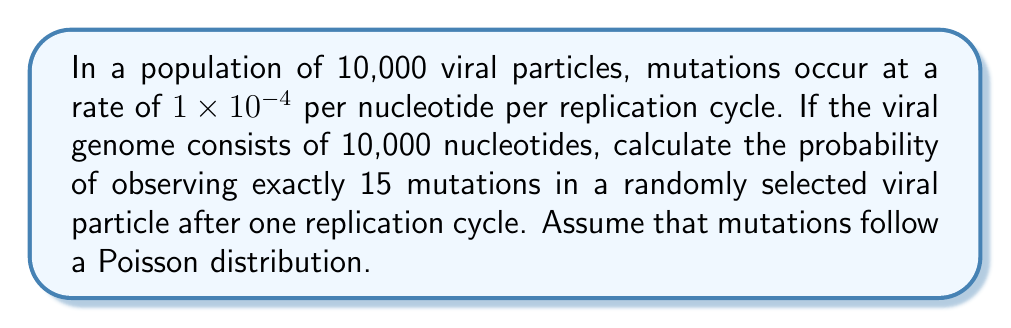Show me your answer to this math problem. To solve this problem, we'll follow these steps:

1) First, we need to calculate the average number of mutations per viral particle (λ):
   $\lambda = \text{mutation rate} \times \text{number of nucleotides}$
   $\lambda = (1 \times 10^{-4}) \times 10,000 = 1$

2) Now that we have λ, we can use the Poisson distribution formula:
   $$P(X = k) = \frac{e^{-\lambda} \lambda^k}{k!}$$
   Where:
   - $P(X = k)$ is the probability of observing exactly $k$ events
   - $e$ is Euler's number (approximately 2.71828)
   - $\lambda$ is the average number of events in the interval
   - $k$ is the number of events we're interested in

3) We want to find $P(X = 15)$, so we substitute our values:
   $$P(X = 15) = \frac{e^{-1} 1^{15}}{15!}$$

4) Simplify:
   $$P(X = 15) = \frac{e^{-1}}{15!}$$

5) Calculate:
   $$P(X = 15) \approx \frac{0.36788}{1,307,674,368,000} \approx 2.81 \times 10^{-13}$$

This extremely low probability indicates that observing exactly 15 mutations in a single viral particle is a very rare event under these conditions.
Answer: $2.81 \times 10^{-13}$ 